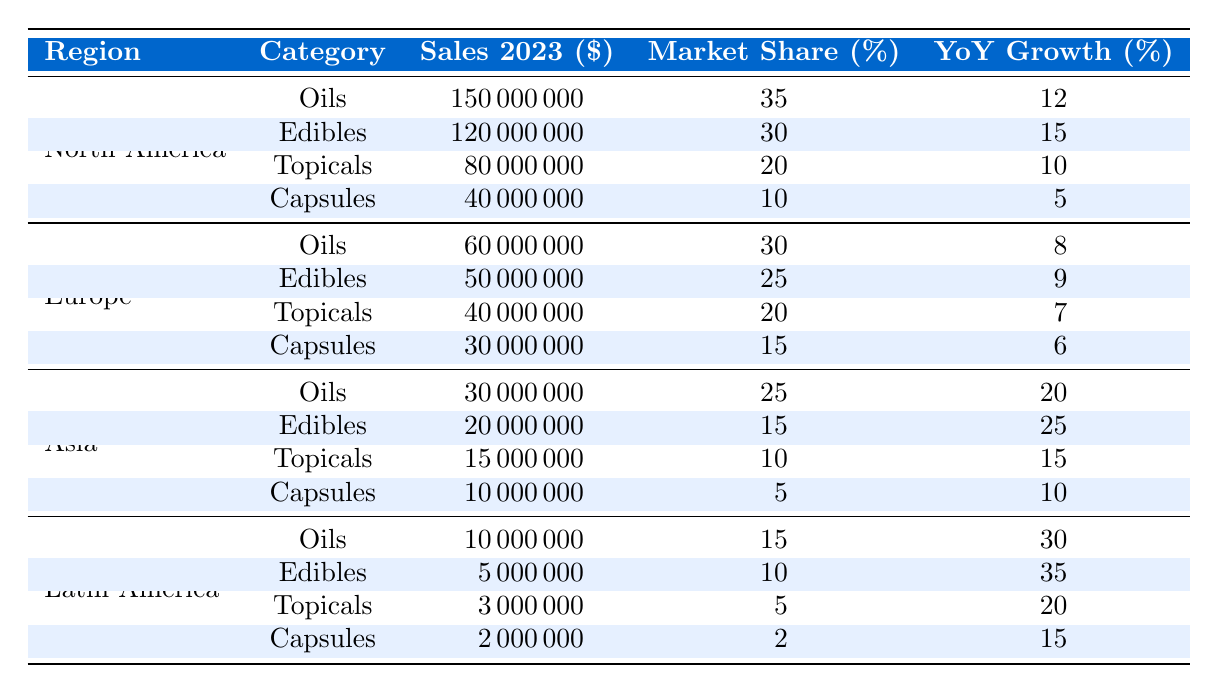What is the total sales for CBD oils in North America? To find the total sales for CBD oils in North America, we look at the specific row for oils under the North America region in the table. The sales amount is given as $150,000,000.
Answer: 150000000 Which category had the highest market share in North America? In the North America section, we compare the market shares of all categories: Oils (35%), Edibles (30%), Topicals (20%), and Capsules (10%). Oils have the highest market share at 35%.
Answer: Oils What percentage increase in sales did Edibles see compared to the previous year in North America? The year-on-year growth percentage for Edibles in North America is listed in the table as 15%. This means their sales increased by 15% compared to the previous year.
Answer: 15% How many total sales (in dollars) did Asia generate from Edibles, Topicals, and Capsules combined? For Asia, the sales figures are: Edibles ($20,000,000), Topicals ($15,000,000), and Capsules ($10,000,000). Summing these amounts gives us $20,000,000 + $15,000,000 + $10,000,000 = $45,000,000.
Answer: 45000000 Is the market share for Topicals in Latin America greater than 5%? The table shows that the market share for Topicals in Latin America is 5%. Since 5% is not greater than itself, the answer is no.
Answer: No Which region experienced the highest year-on-year growth rate for CBD Capsules? From the table, North America has YoY growth of 5%, Europe has 6%, Asia has 10%, and Latin America has 15%. Latin America experienced the highest growth at 15%.
Answer: Latin America What is the average sales figure for all CBD product categories in Europe? To calculate the average, we take the total sales from all categories in Europe: Oils ($60,000,000), Edibles ($50,000,000), Topicals ($40,000,000), and Capsules ($30,000,000). Their total is $60,000,000 + $50,000,000 + $40,000,000 + $30,000,000 = $180,000,000. Dividing by the number of categories (4), we get $180,000,000 / 4 = $45,000,000.
Answer: 45000000 What region has the lowest total sales across all categories? To find this, we sum the sales across all categories for each region: North America ($390,000,000), Europe ($150,000,000), Asia ($70,000,000), and Latin America ($20,000,000). The lowest total sales are from Latin America at $20,000,000.
Answer: Latin America Which product category had the largest year-on-year growth in Asia? Looking at the YoY growth percentages for Asia: Oils (20%), Edibles (25%), Topicals (15%), and Capsules (10%). The highest growth is from Edibles at 25%.
Answer: Edibles Did the total sales for Edibles in North America exceed those in Europe in 2023? The sales for Edibles are $120,000,000 in North America and $50,000,000 in Europe. Since $120,000,000 is greater than $50,000,000, the answer is yes.
Answer: Yes 